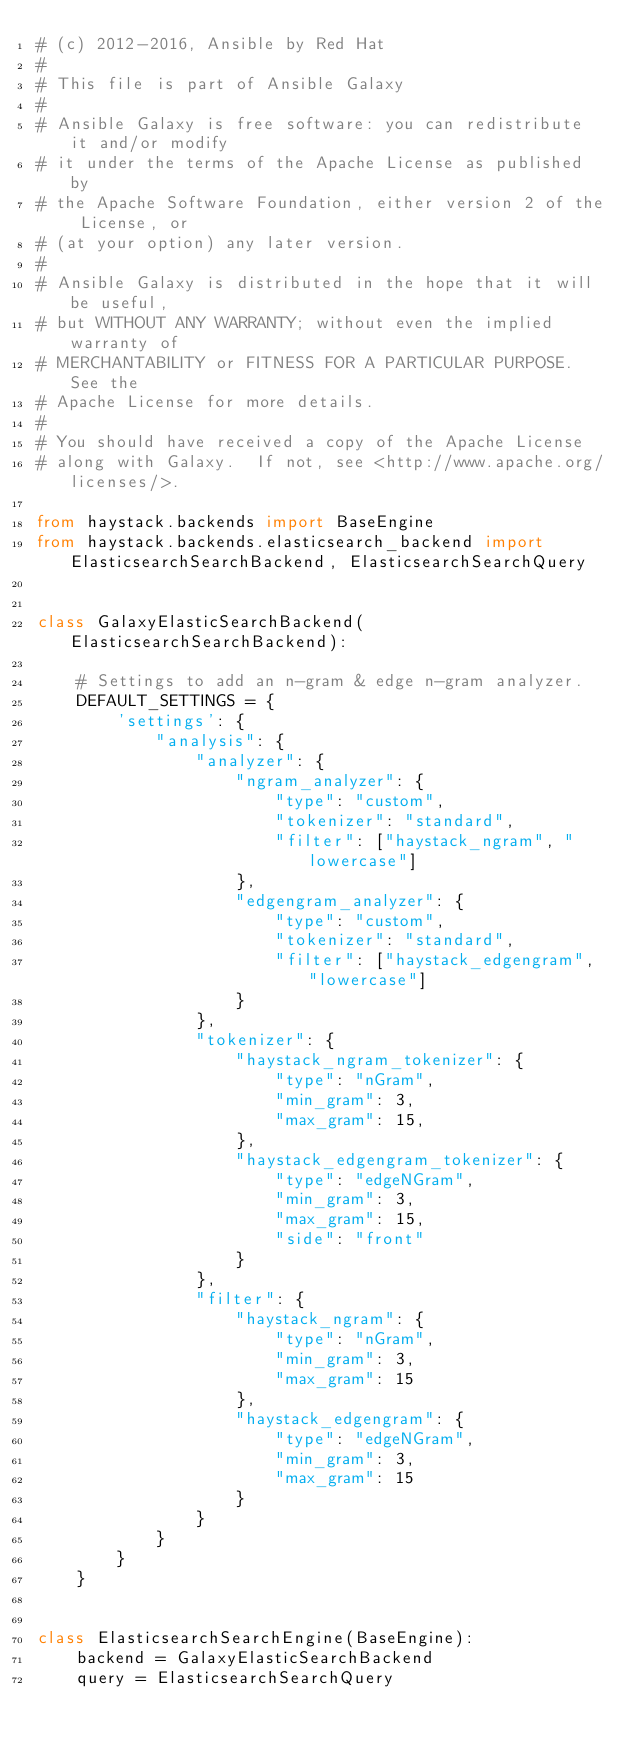Convert code to text. <code><loc_0><loc_0><loc_500><loc_500><_Python_># (c) 2012-2016, Ansible by Red Hat
#
# This file is part of Ansible Galaxy
#
# Ansible Galaxy is free software: you can redistribute it and/or modify
# it under the terms of the Apache License as published by
# the Apache Software Foundation, either version 2 of the License, or
# (at your option) any later version.
#
# Ansible Galaxy is distributed in the hope that it will be useful,
# but WITHOUT ANY WARRANTY; without even the implied warranty of
# MERCHANTABILITY or FITNESS FOR A PARTICULAR PURPOSE.  See the
# Apache License for more details.
#
# You should have received a copy of the Apache License
# along with Galaxy.  If not, see <http://www.apache.org/licenses/>.

from haystack.backends import BaseEngine
from haystack.backends.elasticsearch_backend import ElasticsearchSearchBackend, ElasticsearchSearchQuery


class GalaxyElasticSearchBackend(ElasticsearchSearchBackend):

    # Settings to add an n-gram & edge n-gram analyzer.
    DEFAULT_SETTINGS = {
        'settings': {
            "analysis": {
                "analyzer": {
                    "ngram_analyzer": {
                        "type": "custom",
                        "tokenizer": "standard",
                        "filter": ["haystack_ngram", "lowercase"]
                    },
                    "edgengram_analyzer": {
                        "type": "custom",
                        "tokenizer": "standard",
                        "filter": ["haystack_edgengram", "lowercase"]
                    }
                },
                "tokenizer": {
                    "haystack_ngram_tokenizer": {
                        "type": "nGram",
                        "min_gram": 3,
                        "max_gram": 15,
                    },
                    "haystack_edgengram_tokenizer": {
                        "type": "edgeNGram",
                        "min_gram": 3,
                        "max_gram": 15,
                        "side": "front"
                    }
                },
                "filter": {
                    "haystack_ngram": {
                        "type": "nGram",
                        "min_gram": 3,
                        "max_gram": 15
                    },
                    "haystack_edgengram": {
                        "type": "edgeNGram",
                        "min_gram": 3,
                        "max_gram": 15
                    }
                }
            }
        }
    }


class ElasticsearchSearchEngine(BaseEngine):
    backend = GalaxyElasticSearchBackend
    query = ElasticsearchSearchQuery

</code> 